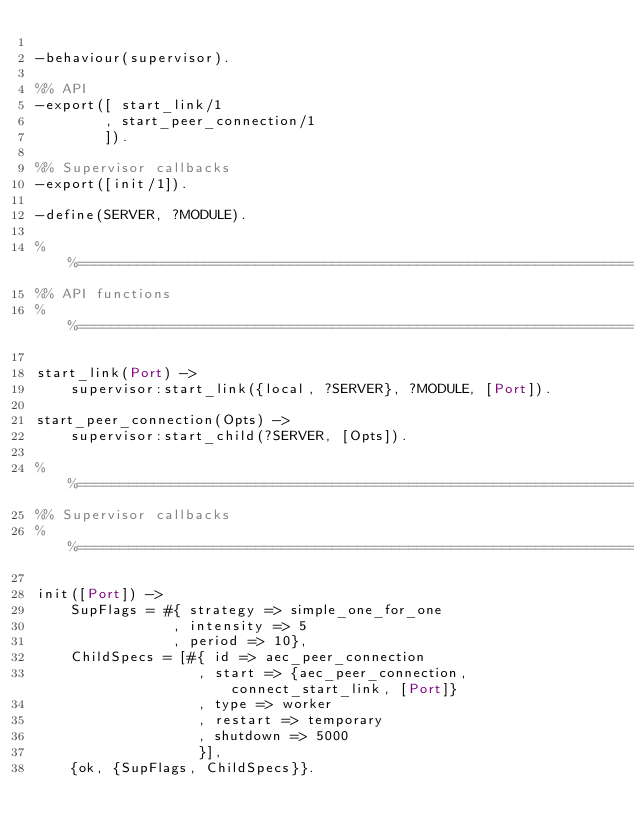<code> <loc_0><loc_0><loc_500><loc_500><_Erlang_>
-behaviour(supervisor).

%% API
-export([ start_link/1
        , start_peer_connection/1
        ]).

%% Supervisor callbacks
-export([init/1]).

-define(SERVER, ?MODULE).

%%====================================================================
%% API functions
%%====================================================================

start_link(Port) ->
    supervisor:start_link({local, ?SERVER}, ?MODULE, [Port]).

start_peer_connection(Opts) ->
    supervisor:start_child(?SERVER, [Opts]).

%%====================================================================
%% Supervisor callbacks
%%====================================================================

init([Port]) ->
    SupFlags = #{ strategy => simple_one_for_one
                , intensity => 5
                , period => 10},
    ChildSpecs = [#{ id => aec_peer_connection
                   , start => {aec_peer_connection, connect_start_link, [Port]}
                   , type => worker
                   , restart => temporary
                   , shutdown => 5000
                   }],
    {ok, {SupFlags, ChildSpecs}}.


</code> 